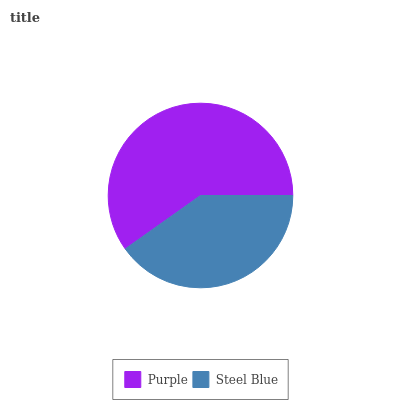Is Steel Blue the minimum?
Answer yes or no. Yes. Is Purple the maximum?
Answer yes or no. Yes. Is Steel Blue the maximum?
Answer yes or no. No. Is Purple greater than Steel Blue?
Answer yes or no. Yes. Is Steel Blue less than Purple?
Answer yes or no. Yes. Is Steel Blue greater than Purple?
Answer yes or no. No. Is Purple less than Steel Blue?
Answer yes or no. No. Is Purple the high median?
Answer yes or no. Yes. Is Steel Blue the low median?
Answer yes or no. Yes. Is Steel Blue the high median?
Answer yes or no. No. Is Purple the low median?
Answer yes or no. No. 